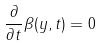Convert formula to latex. <formula><loc_0><loc_0><loc_500><loc_500>\frac { \partial } { \partial t } \beta ( y , t ) = 0</formula> 